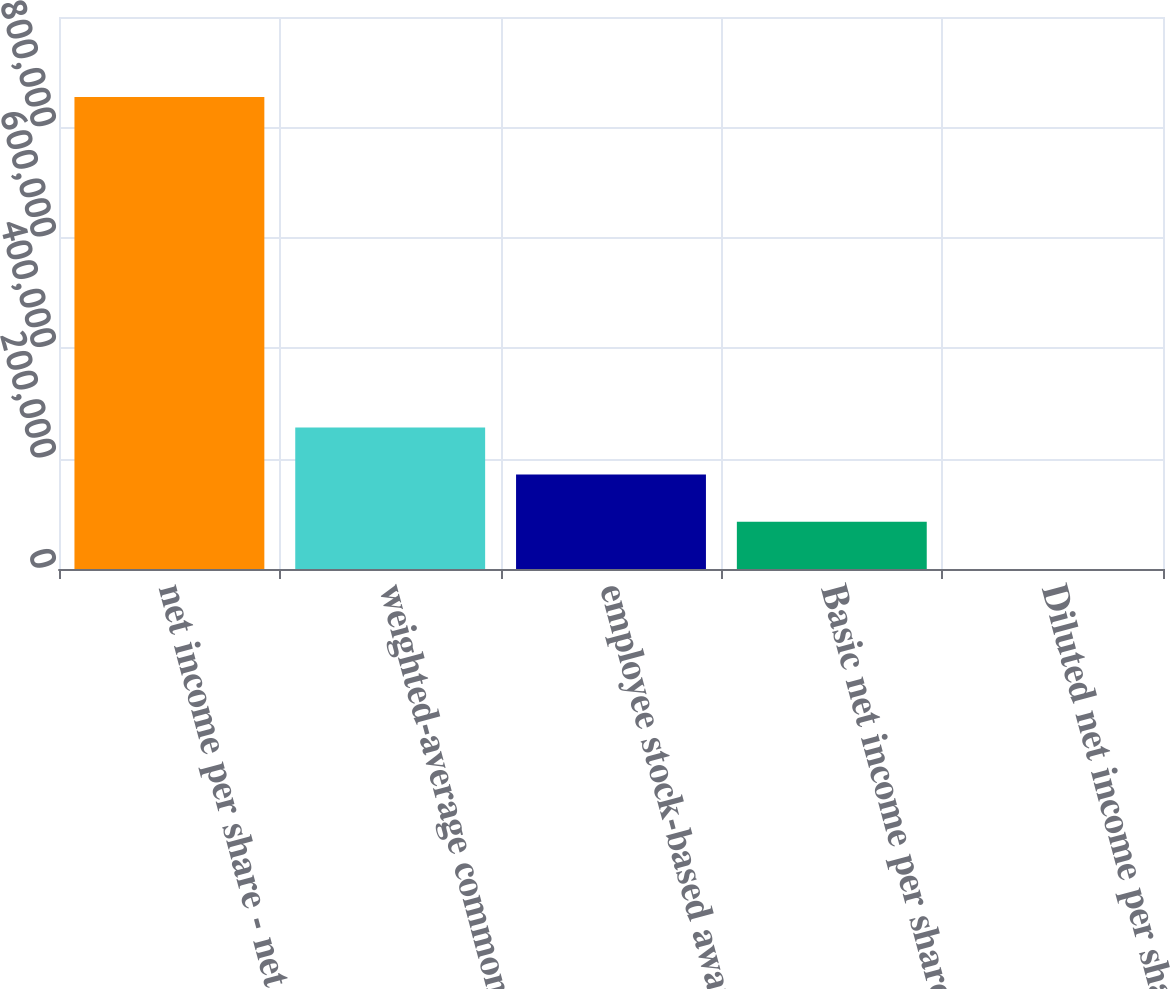Convert chart. <chart><loc_0><loc_0><loc_500><loc_500><bar_chart><fcel>net income per share - net<fcel>weighted-average common shares<fcel>employee stock-based awards<fcel>Basic net income per share<fcel>Diluted net income per share<nl><fcel>855011<fcel>256506<fcel>171005<fcel>85504.6<fcel>3.89<nl></chart> 